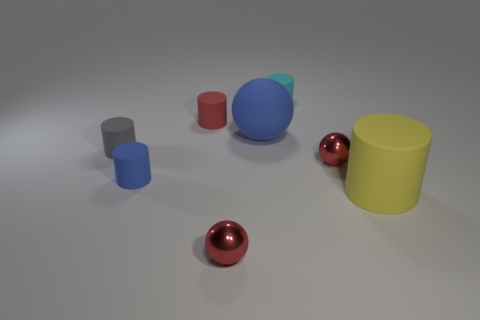Subtract 1 cylinders. How many cylinders are left? 4 Subtract all red cylinders. How many cylinders are left? 4 Subtract all red cylinders. How many cylinders are left? 4 Subtract all green cylinders. Subtract all gray balls. How many cylinders are left? 5 Add 1 matte things. How many objects exist? 9 Subtract all cylinders. How many objects are left? 3 Subtract all tiny blue cylinders. Subtract all small gray objects. How many objects are left? 6 Add 8 big yellow rubber cylinders. How many big yellow rubber cylinders are left? 9 Add 3 tiny gray rubber cylinders. How many tiny gray rubber cylinders exist? 4 Subtract 1 cyan cylinders. How many objects are left? 7 